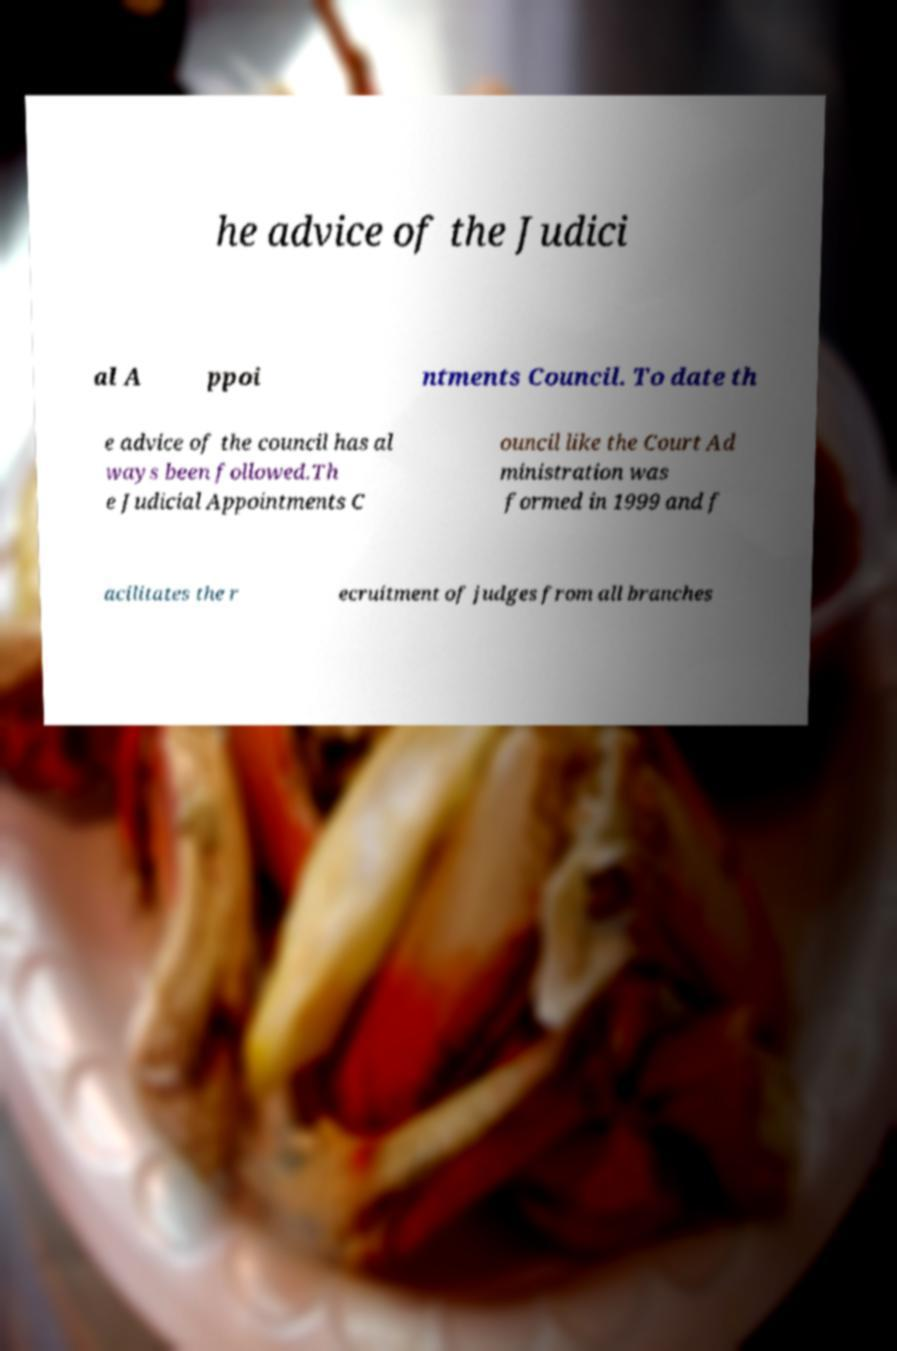For documentation purposes, I need the text within this image transcribed. Could you provide that? he advice of the Judici al A ppoi ntments Council. To date th e advice of the council has al ways been followed.Th e Judicial Appointments C ouncil like the Court Ad ministration was formed in 1999 and f acilitates the r ecruitment of judges from all branches 